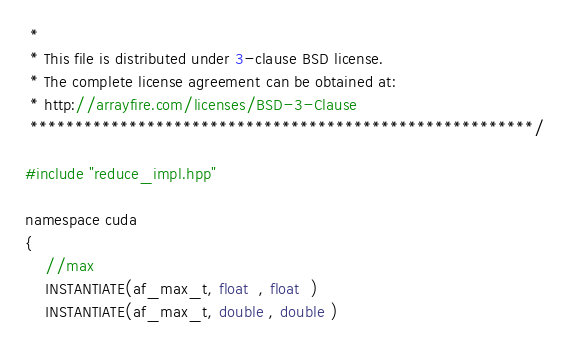Convert code to text. <code><loc_0><loc_0><loc_500><loc_500><_Cuda_> *
 * This file is distributed under 3-clause BSD license.
 * The complete license agreement can be obtained at:
 * http://arrayfire.com/licenses/BSD-3-Clause
 ********************************************************/

#include "reduce_impl.hpp"

namespace cuda
{
    //max
    INSTANTIATE(af_max_t, float  , float  )
    INSTANTIATE(af_max_t, double , double )</code> 